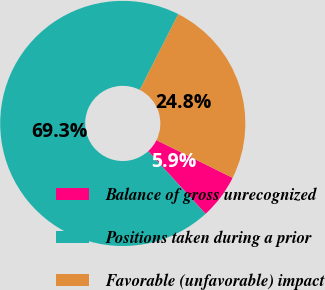Convert chart. <chart><loc_0><loc_0><loc_500><loc_500><pie_chart><fcel>Balance of gross unrecognized<fcel>Positions taken during a prior<fcel>Favorable (unfavorable) impact<nl><fcel>5.88%<fcel>69.28%<fcel>24.84%<nl></chart> 